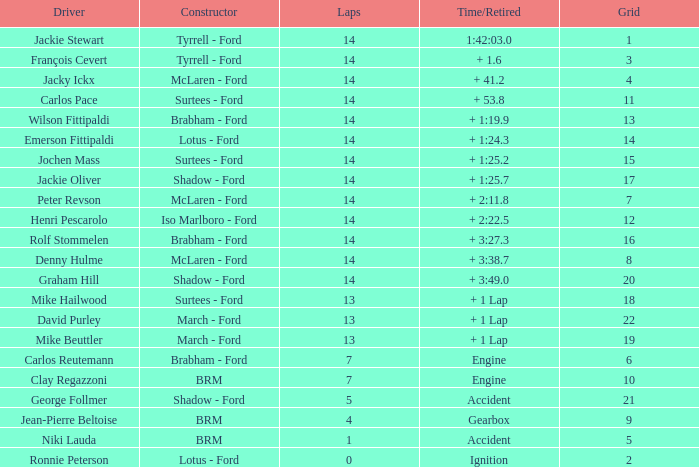What is the minimum lap count for henri pescarolo with a grade higher than 6? 14.0. 